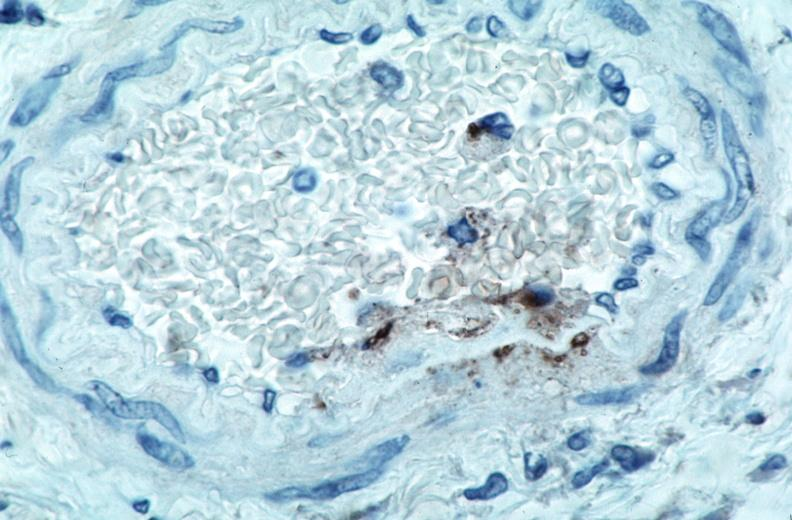what is present?
Answer the question using a single word or phrase. Vasculature 